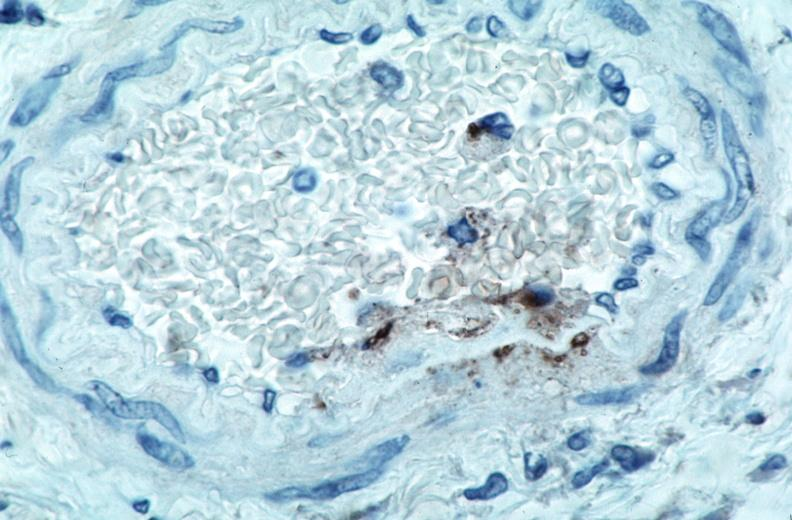what is present?
Answer the question using a single word or phrase. Vasculature 